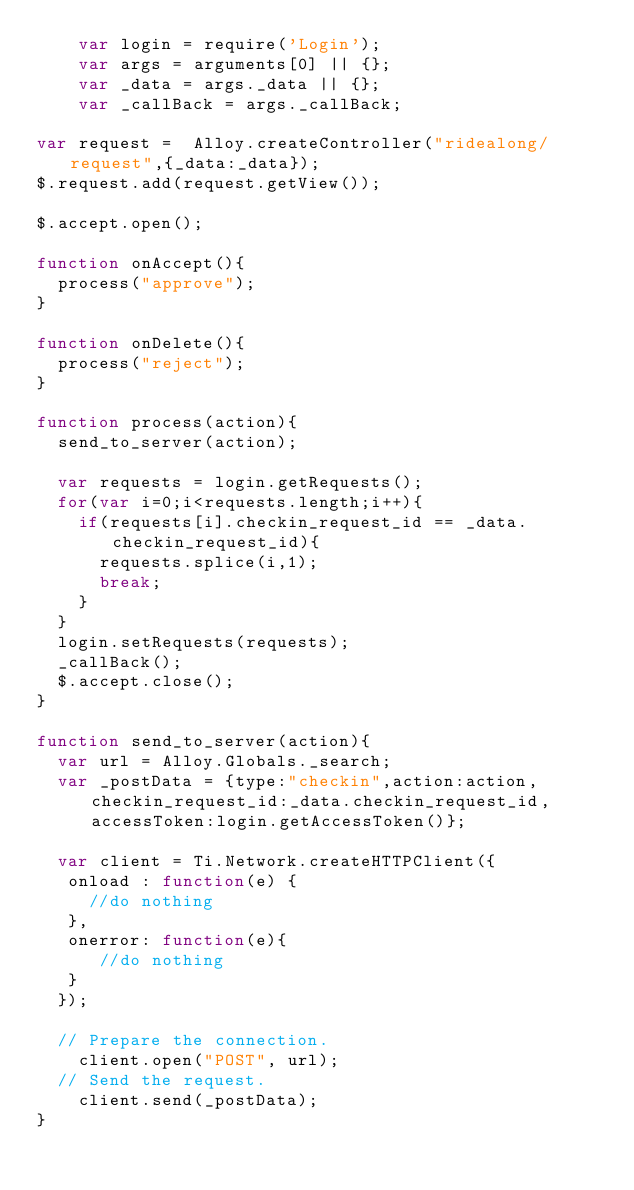<code> <loc_0><loc_0><loc_500><loc_500><_JavaScript_>		var login = require('Login');
		var args = arguments[0] || {};
		var _data = args._data || {};
		var _callBack = args._callBack;
		
var request =  Alloy.createController("ridealong/request",{_data:_data});
$.request.add(request.getView());

$.accept.open();

function onAccept(){
	process("approve");
}

function onDelete(){
	process("reject");
}

function process(action){
	send_to_server(action);
	
	var requests = login.getRequests();
	for(var i=0;i<requests.length;i++){
		if(requests[i].checkin_request_id == _data.checkin_request_id){
			requests.splice(i,1);
			break;
		}
	}
	login.setRequests(requests);
	_callBack();
	$.accept.close();
}

function send_to_server(action){
	var url = Alloy.Globals._search;	
	var _postData = {type:"checkin",action:action,checkin_request_id:_data.checkin_request_id,accessToken:login.getAccessToken()};
	
 	var client = Ti.Network.createHTTPClient({ 		
 	 onload : function(e) {
 	 	 //do nothing
 	 },
 	 onerror: function(e){
 		 	//do nothing
 	 }
 	});
 	
 	// Prepare the connection.
 		client.open("POST", url);
 	// Send the request.
 		client.send(_postData);
}
</code> 